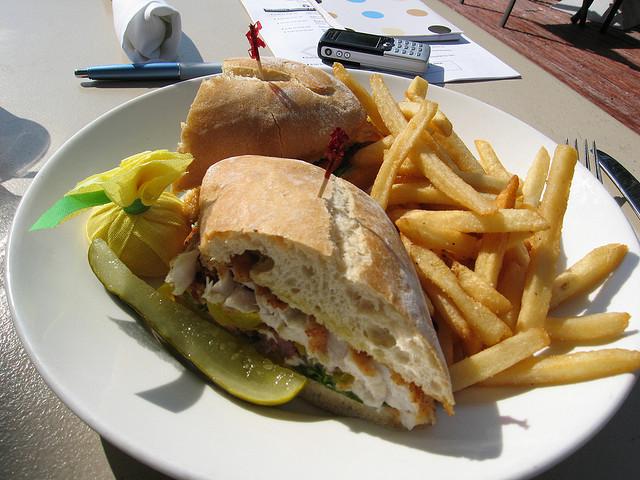Has the pickle been eaten at all?
Concise answer only. No. Is this table for two diners?
Give a very brief answer. No. What type of meat on the sandwich?
Short answer required. Chicken. What is on this sub?
Keep it brief. Chicken. Is there a mobile phone next to the plate?
Keep it brief. Yes. What is the table made of?
Concise answer only. Plastic. How many layers is this sandwich?
Keep it brief. 1. What is served other than hot dogs?
Be succinct. Fries. Is it cole slaw?
Answer briefly. No. Which food is this?
Quick response, please. Sandwich and fries. What is under the pickle?
Concise answer only. Plate. Are the fries seasoned?
Concise answer only. No. Can you see a dill pickle?
Be succinct. Yes. What is the little red thing on the plate next to the French fry?
Give a very brief answer. Toothpick. Is there a fried egg on the sandwich?
Give a very brief answer. No. What kind of sandwich is on the plate?
Give a very brief answer. Chicken. Is the sandwich grilled?
Give a very brief answer. No. Is there cheese on the plate?
Give a very brief answer. No. What type of bun does this burger have?
Answer briefly. Sourdough. What kind of potato are they having?
Short answer required. French fries. Where is the fries?
Quick response, please. On plate. Is this a chicken sandwich?
Quick response, please. Yes. Is there a lot of lettuce on this sandwich?
Short answer required. No. Is there a fried egg on top of one of the sandwiches?
Answer briefly. No. 